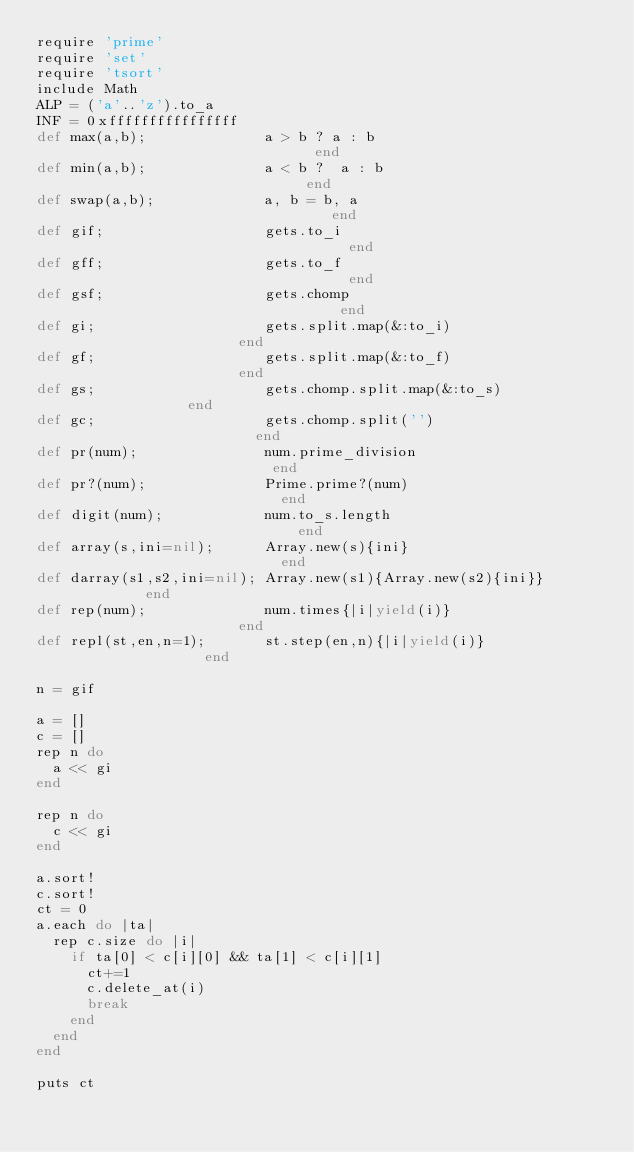Convert code to text. <code><loc_0><loc_0><loc_500><loc_500><_Ruby_>require 'prime'
require 'set'
require 'tsort'
include Math
ALP = ('a'..'z').to_a
INF = 0xffffffffffffffff
def max(a,b);              a > b ? a : b                              end
def min(a,b);              a < b ?  a : b                             end
def swap(a,b);             a, b = b, a                                end
def gif;                   gets.to_i                                  end
def gff;                   gets.to_f                                  end
def gsf;                   gets.chomp                                 end
def gi;                    gets.split.map(&:to_i)                     end
def gf;                    gets.split.map(&:to_f)                     end
def gs;                    gets.chomp.split.map(&:to_s)               end
def gc;                    gets.chomp.split('')                       end
def pr(num);               num.prime_division                         end
def pr?(num);              Prime.prime?(num)                          end
def digit(num);            num.to_s.length                            end
def array(s,ini=nil);      Array.new(s){ini}                          end
def darray(s1,s2,ini=nil); Array.new(s1){Array.new(s2){ini}}          end
def rep(num);              num.times{|i|yield(i)}                     end
def repl(st,en,n=1);       st.step(en,n){|i|yield(i)}                 end

n = gif

a = []
c = []
rep n do
  a << gi
end

rep n do
  c << gi
end

a.sort!
c.sort!
ct = 0
a.each do |ta|
  rep c.size do |i|
    if ta[0] < c[i][0] && ta[1] < c[i][1]
      ct+=1
      c.delete_at(i)
      break
    end
  end
end

puts ct
</code> 